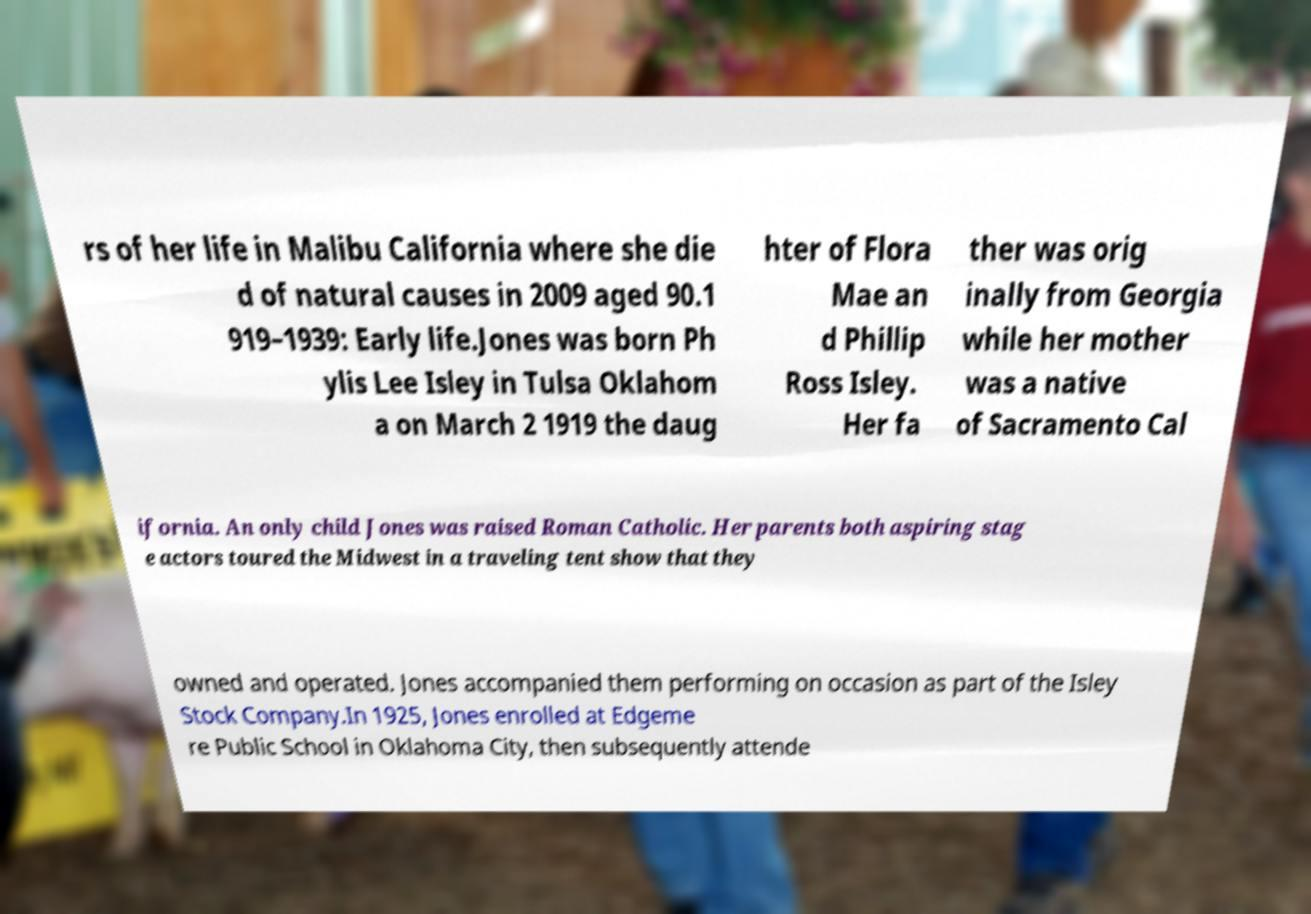Please read and relay the text visible in this image. What does it say? rs of her life in Malibu California where she die d of natural causes in 2009 aged 90.1 919–1939: Early life.Jones was born Ph ylis Lee Isley in Tulsa Oklahom a on March 2 1919 the daug hter of Flora Mae an d Phillip Ross Isley. Her fa ther was orig inally from Georgia while her mother was a native of Sacramento Cal ifornia. An only child Jones was raised Roman Catholic. Her parents both aspiring stag e actors toured the Midwest in a traveling tent show that they owned and operated. Jones accompanied them performing on occasion as part of the Isley Stock Company.In 1925, Jones enrolled at Edgeme re Public School in Oklahoma City, then subsequently attende 